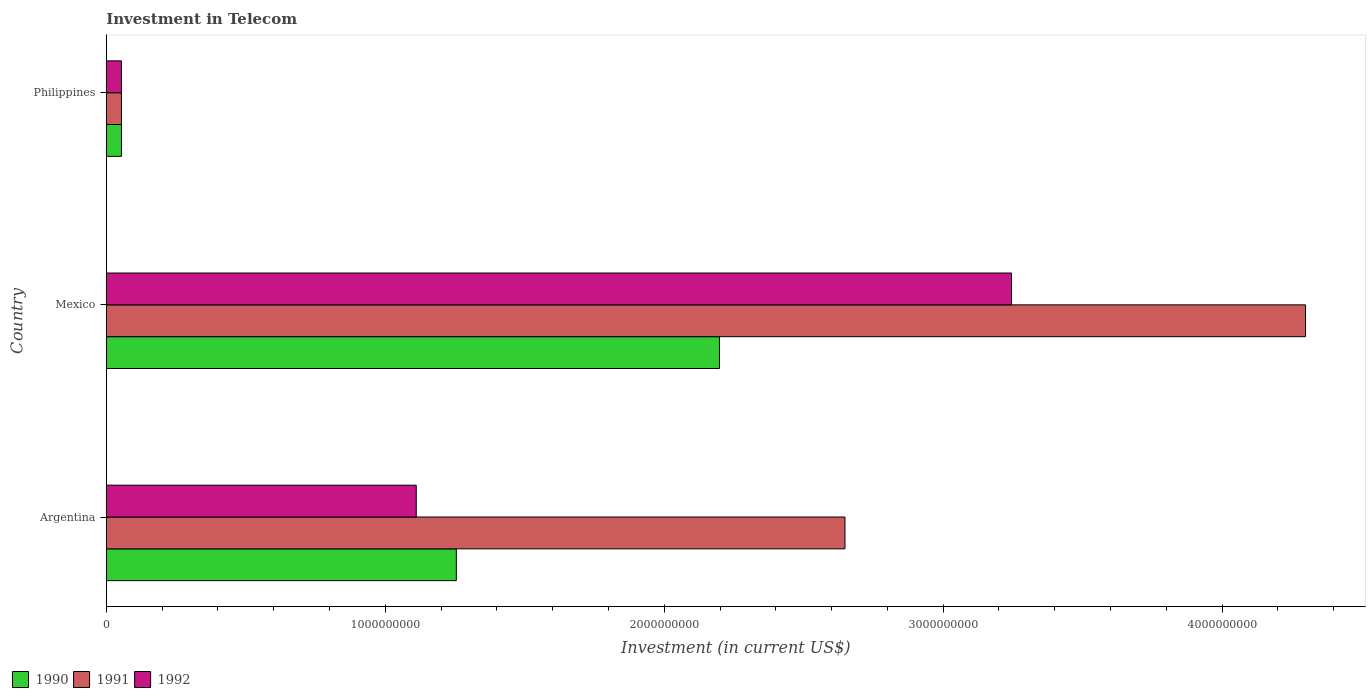How many different coloured bars are there?
Offer a terse response. 3. How many groups of bars are there?
Keep it short and to the point. 3. Are the number of bars on each tick of the Y-axis equal?
Offer a very short reply. Yes. How many bars are there on the 3rd tick from the bottom?
Offer a terse response. 3. What is the label of the 1st group of bars from the top?
Offer a terse response. Philippines. What is the amount invested in telecom in 1991 in Mexico?
Provide a short and direct response. 4.30e+09. Across all countries, what is the maximum amount invested in telecom in 1991?
Offer a very short reply. 4.30e+09. Across all countries, what is the minimum amount invested in telecom in 1991?
Provide a succinct answer. 5.42e+07. In which country was the amount invested in telecom in 1992 maximum?
Offer a terse response. Mexico. In which country was the amount invested in telecom in 1992 minimum?
Give a very brief answer. Philippines. What is the total amount invested in telecom in 1991 in the graph?
Provide a succinct answer. 7.00e+09. What is the difference between the amount invested in telecom in 1992 in Argentina and that in Mexico?
Your answer should be compact. -2.13e+09. What is the difference between the amount invested in telecom in 1990 in Philippines and the amount invested in telecom in 1991 in Mexico?
Offer a terse response. -4.24e+09. What is the average amount invested in telecom in 1992 per country?
Make the answer very short. 1.47e+09. What is the difference between the amount invested in telecom in 1991 and amount invested in telecom in 1990 in Philippines?
Offer a terse response. 0. In how many countries, is the amount invested in telecom in 1990 greater than 3800000000 US$?
Your answer should be compact. 0. What is the ratio of the amount invested in telecom in 1990 in Argentina to that in Philippines?
Offer a very short reply. 23.15. Is the amount invested in telecom in 1991 in Mexico less than that in Philippines?
Keep it short and to the point. No. Is the difference between the amount invested in telecom in 1991 in Mexico and Philippines greater than the difference between the amount invested in telecom in 1990 in Mexico and Philippines?
Provide a succinct answer. Yes. What is the difference between the highest and the second highest amount invested in telecom in 1990?
Make the answer very short. 9.43e+08. What is the difference between the highest and the lowest amount invested in telecom in 1992?
Provide a short and direct response. 3.19e+09. Is the sum of the amount invested in telecom in 1991 in Mexico and Philippines greater than the maximum amount invested in telecom in 1992 across all countries?
Offer a terse response. Yes. What does the 2nd bar from the top in Argentina represents?
Your response must be concise. 1991. Is it the case that in every country, the sum of the amount invested in telecom in 1990 and amount invested in telecom in 1992 is greater than the amount invested in telecom in 1991?
Your answer should be compact. No. How many bars are there?
Your response must be concise. 9. Are all the bars in the graph horizontal?
Make the answer very short. Yes. What is the difference between two consecutive major ticks on the X-axis?
Your answer should be compact. 1.00e+09. Does the graph contain any zero values?
Provide a succinct answer. No. Does the graph contain grids?
Offer a very short reply. No. Where does the legend appear in the graph?
Provide a succinct answer. Bottom left. How many legend labels are there?
Make the answer very short. 3. How are the legend labels stacked?
Give a very brief answer. Horizontal. What is the title of the graph?
Provide a short and direct response. Investment in Telecom. What is the label or title of the X-axis?
Your answer should be compact. Investment (in current US$). What is the Investment (in current US$) in 1990 in Argentina?
Make the answer very short. 1.25e+09. What is the Investment (in current US$) of 1991 in Argentina?
Keep it short and to the point. 2.65e+09. What is the Investment (in current US$) in 1992 in Argentina?
Give a very brief answer. 1.11e+09. What is the Investment (in current US$) in 1990 in Mexico?
Your answer should be very brief. 2.20e+09. What is the Investment (in current US$) in 1991 in Mexico?
Your answer should be compact. 4.30e+09. What is the Investment (in current US$) of 1992 in Mexico?
Keep it short and to the point. 3.24e+09. What is the Investment (in current US$) in 1990 in Philippines?
Give a very brief answer. 5.42e+07. What is the Investment (in current US$) in 1991 in Philippines?
Keep it short and to the point. 5.42e+07. What is the Investment (in current US$) of 1992 in Philippines?
Your response must be concise. 5.42e+07. Across all countries, what is the maximum Investment (in current US$) of 1990?
Your response must be concise. 2.20e+09. Across all countries, what is the maximum Investment (in current US$) of 1991?
Keep it short and to the point. 4.30e+09. Across all countries, what is the maximum Investment (in current US$) of 1992?
Your response must be concise. 3.24e+09. Across all countries, what is the minimum Investment (in current US$) in 1990?
Your answer should be very brief. 5.42e+07. Across all countries, what is the minimum Investment (in current US$) of 1991?
Your response must be concise. 5.42e+07. Across all countries, what is the minimum Investment (in current US$) in 1992?
Provide a succinct answer. 5.42e+07. What is the total Investment (in current US$) of 1990 in the graph?
Provide a short and direct response. 3.51e+09. What is the total Investment (in current US$) of 1991 in the graph?
Keep it short and to the point. 7.00e+09. What is the total Investment (in current US$) of 1992 in the graph?
Offer a terse response. 4.41e+09. What is the difference between the Investment (in current US$) of 1990 in Argentina and that in Mexico?
Offer a very short reply. -9.43e+08. What is the difference between the Investment (in current US$) in 1991 in Argentina and that in Mexico?
Offer a terse response. -1.65e+09. What is the difference between the Investment (in current US$) of 1992 in Argentina and that in Mexico?
Offer a terse response. -2.13e+09. What is the difference between the Investment (in current US$) of 1990 in Argentina and that in Philippines?
Provide a succinct answer. 1.20e+09. What is the difference between the Investment (in current US$) in 1991 in Argentina and that in Philippines?
Give a very brief answer. 2.59e+09. What is the difference between the Investment (in current US$) in 1992 in Argentina and that in Philippines?
Make the answer very short. 1.06e+09. What is the difference between the Investment (in current US$) in 1990 in Mexico and that in Philippines?
Offer a very short reply. 2.14e+09. What is the difference between the Investment (in current US$) of 1991 in Mexico and that in Philippines?
Offer a very short reply. 4.24e+09. What is the difference between the Investment (in current US$) of 1992 in Mexico and that in Philippines?
Keep it short and to the point. 3.19e+09. What is the difference between the Investment (in current US$) of 1990 in Argentina and the Investment (in current US$) of 1991 in Mexico?
Provide a succinct answer. -3.04e+09. What is the difference between the Investment (in current US$) in 1990 in Argentina and the Investment (in current US$) in 1992 in Mexico?
Offer a terse response. -1.99e+09. What is the difference between the Investment (in current US$) of 1991 in Argentina and the Investment (in current US$) of 1992 in Mexico?
Your answer should be compact. -5.97e+08. What is the difference between the Investment (in current US$) in 1990 in Argentina and the Investment (in current US$) in 1991 in Philippines?
Provide a short and direct response. 1.20e+09. What is the difference between the Investment (in current US$) in 1990 in Argentina and the Investment (in current US$) in 1992 in Philippines?
Make the answer very short. 1.20e+09. What is the difference between the Investment (in current US$) of 1991 in Argentina and the Investment (in current US$) of 1992 in Philippines?
Offer a very short reply. 2.59e+09. What is the difference between the Investment (in current US$) in 1990 in Mexico and the Investment (in current US$) in 1991 in Philippines?
Provide a succinct answer. 2.14e+09. What is the difference between the Investment (in current US$) in 1990 in Mexico and the Investment (in current US$) in 1992 in Philippines?
Offer a terse response. 2.14e+09. What is the difference between the Investment (in current US$) in 1991 in Mexico and the Investment (in current US$) in 1992 in Philippines?
Your answer should be very brief. 4.24e+09. What is the average Investment (in current US$) in 1990 per country?
Keep it short and to the point. 1.17e+09. What is the average Investment (in current US$) in 1991 per country?
Offer a terse response. 2.33e+09. What is the average Investment (in current US$) in 1992 per country?
Provide a short and direct response. 1.47e+09. What is the difference between the Investment (in current US$) in 1990 and Investment (in current US$) in 1991 in Argentina?
Ensure brevity in your answer.  -1.39e+09. What is the difference between the Investment (in current US$) of 1990 and Investment (in current US$) of 1992 in Argentina?
Make the answer very short. 1.44e+08. What is the difference between the Investment (in current US$) in 1991 and Investment (in current US$) in 1992 in Argentina?
Offer a very short reply. 1.54e+09. What is the difference between the Investment (in current US$) of 1990 and Investment (in current US$) of 1991 in Mexico?
Provide a short and direct response. -2.10e+09. What is the difference between the Investment (in current US$) in 1990 and Investment (in current US$) in 1992 in Mexico?
Provide a short and direct response. -1.05e+09. What is the difference between the Investment (in current US$) of 1991 and Investment (in current US$) of 1992 in Mexico?
Offer a terse response. 1.05e+09. What is the difference between the Investment (in current US$) of 1990 and Investment (in current US$) of 1991 in Philippines?
Give a very brief answer. 0. What is the difference between the Investment (in current US$) in 1990 and Investment (in current US$) in 1992 in Philippines?
Your answer should be very brief. 0. What is the ratio of the Investment (in current US$) of 1990 in Argentina to that in Mexico?
Your answer should be very brief. 0.57. What is the ratio of the Investment (in current US$) of 1991 in Argentina to that in Mexico?
Your answer should be very brief. 0.62. What is the ratio of the Investment (in current US$) in 1992 in Argentina to that in Mexico?
Keep it short and to the point. 0.34. What is the ratio of the Investment (in current US$) in 1990 in Argentina to that in Philippines?
Your answer should be very brief. 23.15. What is the ratio of the Investment (in current US$) of 1991 in Argentina to that in Philippines?
Keep it short and to the point. 48.86. What is the ratio of the Investment (in current US$) of 1992 in Argentina to that in Philippines?
Offer a very short reply. 20.5. What is the ratio of the Investment (in current US$) in 1990 in Mexico to that in Philippines?
Your answer should be compact. 40.55. What is the ratio of the Investment (in current US$) in 1991 in Mexico to that in Philippines?
Ensure brevity in your answer.  79.32. What is the ratio of the Investment (in current US$) in 1992 in Mexico to that in Philippines?
Your answer should be compact. 59.87. What is the difference between the highest and the second highest Investment (in current US$) in 1990?
Offer a very short reply. 9.43e+08. What is the difference between the highest and the second highest Investment (in current US$) of 1991?
Make the answer very short. 1.65e+09. What is the difference between the highest and the second highest Investment (in current US$) in 1992?
Offer a terse response. 2.13e+09. What is the difference between the highest and the lowest Investment (in current US$) in 1990?
Your response must be concise. 2.14e+09. What is the difference between the highest and the lowest Investment (in current US$) of 1991?
Your answer should be very brief. 4.24e+09. What is the difference between the highest and the lowest Investment (in current US$) in 1992?
Make the answer very short. 3.19e+09. 